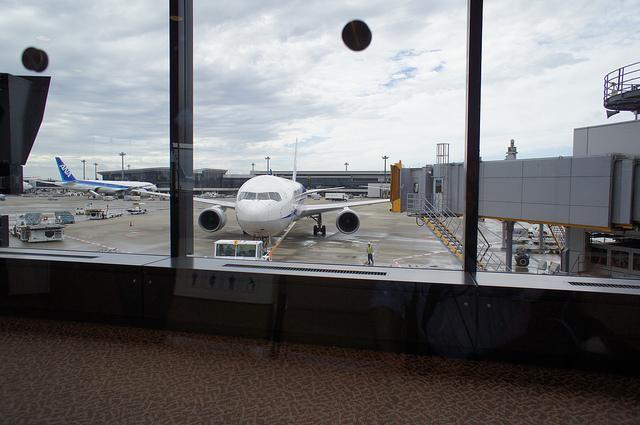Why does the man wear a yellow vest?
Choose the right answer from the provided options to respond to the question.
Options: Visibility, dress code, camouflage, fashion. Visibility. 